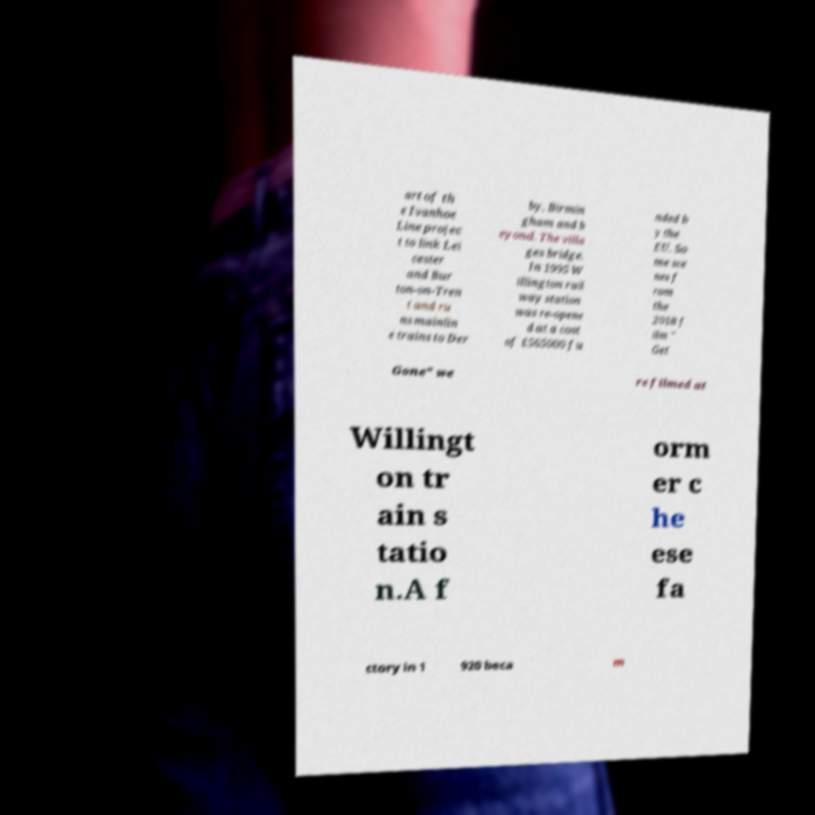For documentation purposes, I need the text within this image transcribed. Could you provide that? art of th e Ivanhoe Line projec t to link Lei cester and Bur ton-on-Tren t and ru ns mainlin e trains to Der by, Birmin gham and b eyond. The villa ges bridge. In 1995 W illington rail way station was re-opene d at a cost of £565000 fu nded b y the EU. So me sce nes f rom the 2018 f ilm " Get Gone" we re filmed at Willingt on tr ain s tatio n.A f orm er c he ese fa ctory in 1 920 beca m 